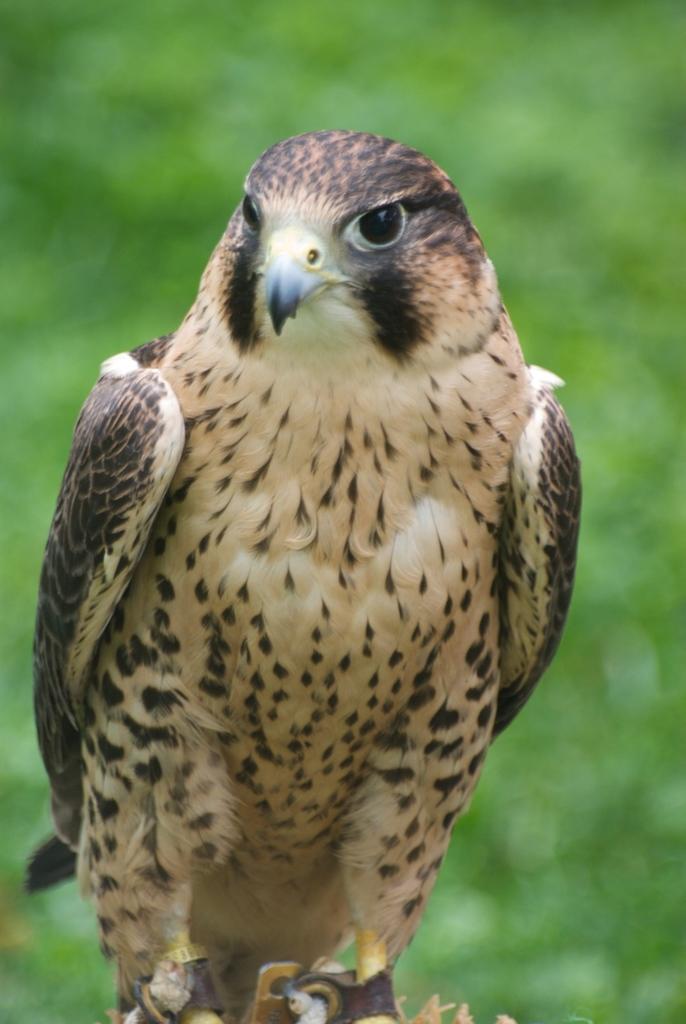Could you give a brief overview of what you see in this image? Here we can see a red-tailed hawk and its legs are tied with a belt. In the background the image is blur. 